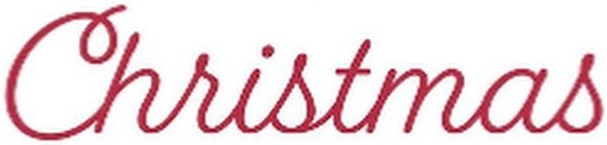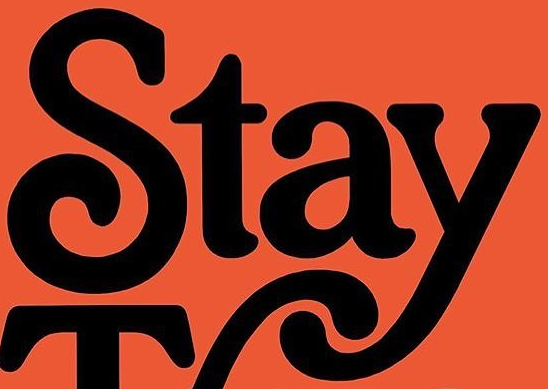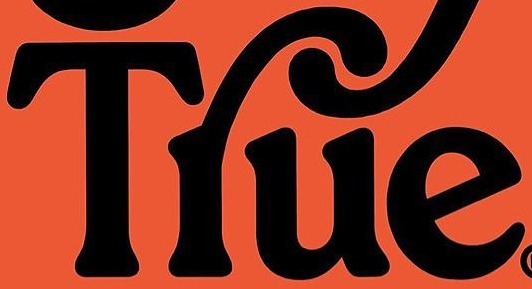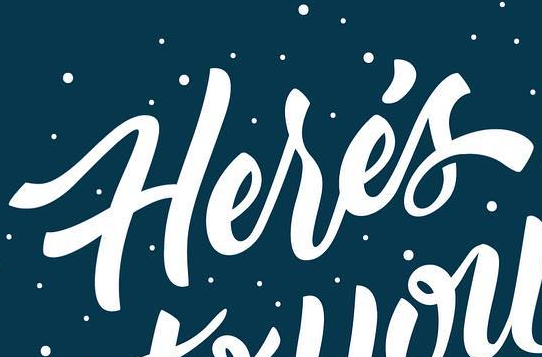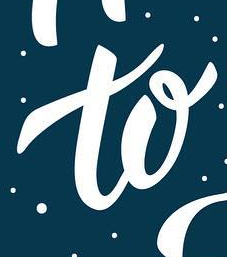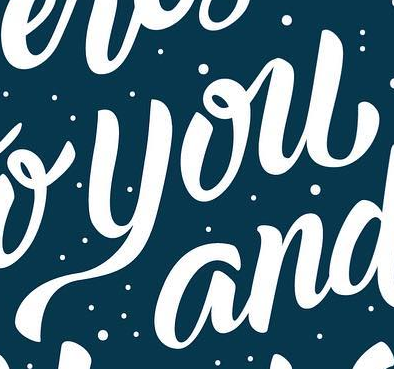Read the text content from these images in order, separated by a semicolon. Christmas; Stay; Tlue; Herés; to; you 